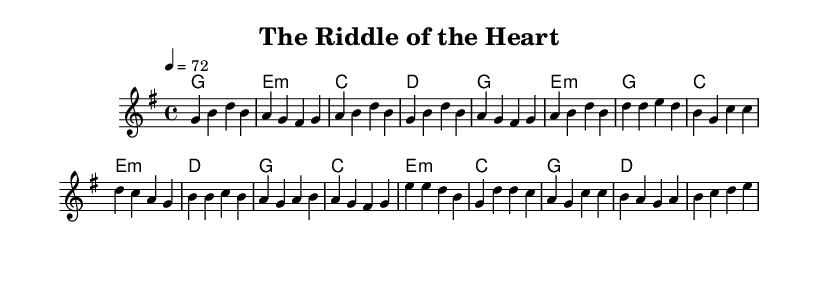What is the key signature of this music? The key signature is G major, which has one sharp (F#).
Answer: G major What is the time signature of this music? The time signature is 4/4, indicating four beats per measure.
Answer: 4/4 What is the tempo marking for this music? The tempo marking is 72 beats per minute, indicating the speed of the piece.
Answer: 72 How many measures are in the verse section? The verse section has six measures, indicated by the grouping of notes before the chorus begins.
Answer: Six What is the first chord of the chorus? The first chord of the chorus is G major, which is indicated at the start of the chorus section in the harmonic notation.
Answer: G How does the bridge differ harmonically from the verse? The bridge section begins with E minor and shifts the harmony compared to the verse, which starts with G major.
Answer: E minor What unique feature of this piece aligns with the country rock genre? The presence of a strong narrative and emotional element in the lyrics and melody, characteristic of country rock ballads, emphasizes storytelling.
Answer: Storytelling 